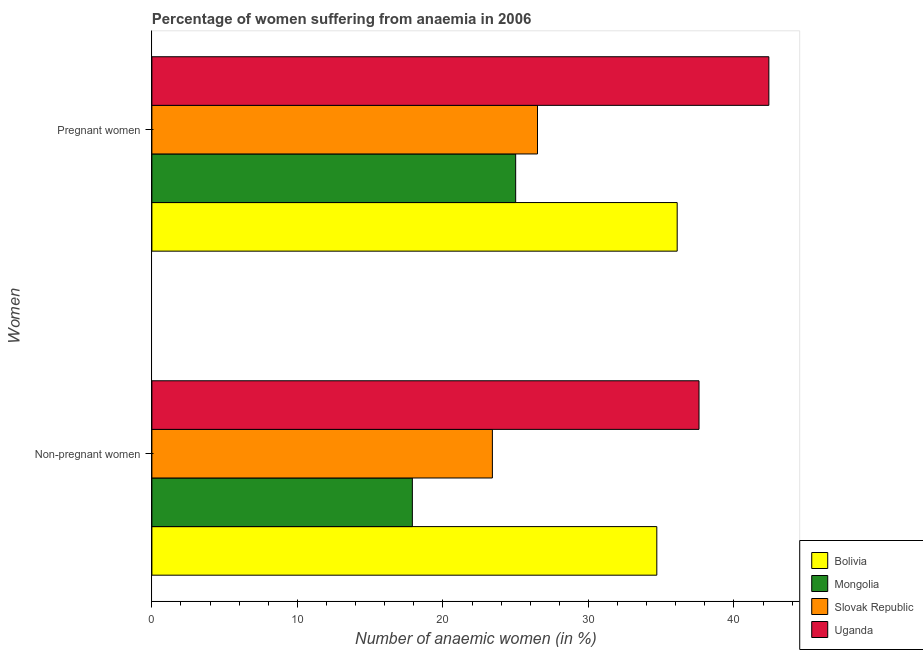How many different coloured bars are there?
Provide a short and direct response. 4. How many groups of bars are there?
Offer a very short reply. 2. How many bars are there on the 2nd tick from the top?
Ensure brevity in your answer.  4. How many bars are there on the 2nd tick from the bottom?
Keep it short and to the point. 4. What is the label of the 2nd group of bars from the top?
Offer a terse response. Non-pregnant women. What is the percentage of non-pregnant anaemic women in Bolivia?
Your answer should be compact. 34.7. Across all countries, what is the maximum percentage of pregnant anaemic women?
Offer a very short reply. 42.4. In which country was the percentage of non-pregnant anaemic women maximum?
Make the answer very short. Uganda. In which country was the percentage of non-pregnant anaemic women minimum?
Provide a succinct answer. Mongolia. What is the total percentage of pregnant anaemic women in the graph?
Your response must be concise. 130. What is the difference between the percentage of non-pregnant anaemic women in Slovak Republic and that in Mongolia?
Your answer should be compact. 5.5. What is the difference between the percentage of non-pregnant anaemic women in Mongolia and the percentage of pregnant anaemic women in Uganda?
Give a very brief answer. -24.5. What is the average percentage of non-pregnant anaemic women per country?
Your response must be concise. 28.4. What is the difference between the percentage of non-pregnant anaemic women and percentage of pregnant anaemic women in Uganda?
Your answer should be very brief. -4.8. What is the ratio of the percentage of non-pregnant anaemic women in Bolivia to that in Uganda?
Make the answer very short. 0.92. In how many countries, is the percentage of pregnant anaemic women greater than the average percentage of pregnant anaemic women taken over all countries?
Make the answer very short. 2. What does the 1st bar from the top in Pregnant women represents?
Ensure brevity in your answer.  Uganda. What does the 3rd bar from the bottom in Non-pregnant women represents?
Ensure brevity in your answer.  Slovak Republic. How many bars are there?
Keep it short and to the point. 8. Are all the bars in the graph horizontal?
Your answer should be compact. Yes. What is the difference between two consecutive major ticks on the X-axis?
Keep it short and to the point. 10. Are the values on the major ticks of X-axis written in scientific E-notation?
Provide a succinct answer. No. Does the graph contain any zero values?
Make the answer very short. No. Where does the legend appear in the graph?
Your answer should be very brief. Bottom right. How many legend labels are there?
Your answer should be very brief. 4. What is the title of the graph?
Provide a succinct answer. Percentage of women suffering from anaemia in 2006. Does "Samoa" appear as one of the legend labels in the graph?
Your answer should be compact. No. What is the label or title of the X-axis?
Offer a very short reply. Number of anaemic women (in %). What is the label or title of the Y-axis?
Your response must be concise. Women. What is the Number of anaemic women (in %) in Bolivia in Non-pregnant women?
Offer a very short reply. 34.7. What is the Number of anaemic women (in %) in Mongolia in Non-pregnant women?
Ensure brevity in your answer.  17.9. What is the Number of anaemic women (in %) in Slovak Republic in Non-pregnant women?
Ensure brevity in your answer.  23.4. What is the Number of anaemic women (in %) of Uganda in Non-pregnant women?
Ensure brevity in your answer.  37.6. What is the Number of anaemic women (in %) of Bolivia in Pregnant women?
Your answer should be very brief. 36.1. What is the Number of anaemic women (in %) of Mongolia in Pregnant women?
Keep it short and to the point. 25. What is the Number of anaemic women (in %) in Uganda in Pregnant women?
Make the answer very short. 42.4. Across all Women, what is the maximum Number of anaemic women (in %) in Bolivia?
Provide a succinct answer. 36.1. Across all Women, what is the maximum Number of anaemic women (in %) of Mongolia?
Provide a succinct answer. 25. Across all Women, what is the maximum Number of anaemic women (in %) of Slovak Republic?
Offer a terse response. 26.5. Across all Women, what is the maximum Number of anaemic women (in %) of Uganda?
Offer a terse response. 42.4. Across all Women, what is the minimum Number of anaemic women (in %) in Bolivia?
Ensure brevity in your answer.  34.7. Across all Women, what is the minimum Number of anaemic women (in %) of Slovak Republic?
Your response must be concise. 23.4. Across all Women, what is the minimum Number of anaemic women (in %) of Uganda?
Your answer should be very brief. 37.6. What is the total Number of anaemic women (in %) in Bolivia in the graph?
Your answer should be compact. 70.8. What is the total Number of anaemic women (in %) in Mongolia in the graph?
Make the answer very short. 42.9. What is the total Number of anaemic women (in %) in Slovak Republic in the graph?
Your response must be concise. 49.9. What is the total Number of anaemic women (in %) in Uganda in the graph?
Keep it short and to the point. 80. What is the difference between the Number of anaemic women (in %) in Bolivia in Non-pregnant women and that in Pregnant women?
Give a very brief answer. -1.4. What is the difference between the Number of anaemic women (in %) of Mongolia in Non-pregnant women and that in Pregnant women?
Keep it short and to the point. -7.1. What is the difference between the Number of anaemic women (in %) in Slovak Republic in Non-pregnant women and that in Pregnant women?
Give a very brief answer. -3.1. What is the difference between the Number of anaemic women (in %) in Bolivia in Non-pregnant women and the Number of anaemic women (in %) in Mongolia in Pregnant women?
Provide a short and direct response. 9.7. What is the difference between the Number of anaemic women (in %) in Bolivia in Non-pregnant women and the Number of anaemic women (in %) in Slovak Republic in Pregnant women?
Provide a succinct answer. 8.2. What is the difference between the Number of anaemic women (in %) in Bolivia in Non-pregnant women and the Number of anaemic women (in %) in Uganda in Pregnant women?
Offer a terse response. -7.7. What is the difference between the Number of anaemic women (in %) in Mongolia in Non-pregnant women and the Number of anaemic women (in %) in Uganda in Pregnant women?
Offer a terse response. -24.5. What is the average Number of anaemic women (in %) in Bolivia per Women?
Give a very brief answer. 35.4. What is the average Number of anaemic women (in %) in Mongolia per Women?
Ensure brevity in your answer.  21.45. What is the average Number of anaemic women (in %) of Slovak Republic per Women?
Ensure brevity in your answer.  24.95. What is the difference between the Number of anaemic women (in %) of Mongolia and Number of anaemic women (in %) of Slovak Republic in Non-pregnant women?
Provide a succinct answer. -5.5. What is the difference between the Number of anaemic women (in %) of Mongolia and Number of anaemic women (in %) of Uganda in Non-pregnant women?
Your answer should be very brief. -19.7. What is the difference between the Number of anaemic women (in %) in Slovak Republic and Number of anaemic women (in %) in Uganda in Non-pregnant women?
Provide a short and direct response. -14.2. What is the difference between the Number of anaemic women (in %) in Bolivia and Number of anaemic women (in %) in Mongolia in Pregnant women?
Make the answer very short. 11.1. What is the difference between the Number of anaemic women (in %) in Bolivia and Number of anaemic women (in %) in Slovak Republic in Pregnant women?
Give a very brief answer. 9.6. What is the difference between the Number of anaemic women (in %) of Bolivia and Number of anaemic women (in %) of Uganda in Pregnant women?
Make the answer very short. -6.3. What is the difference between the Number of anaemic women (in %) in Mongolia and Number of anaemic women (in %) in Uganda in Pregnant women?
Provide a succinct answer. -17.4. What is the difference between the Number of anaemic women (in %) in Slovak Republic and Number of anaemic women (in %) in Uganda in Pregnant women?
Offer a terse response. -15.9. What is the ratio of the Number of anaemic women (in %) of Bolivia in Non-pregnant women to that in Pregnant women?
Keep it short and to the point. 0.96. What is the ratio of the Number of anaemic women (in %) in Mongolia in Non-pregnant women to that in Pregnant women?
Provide a succinct answer. 0.72. What is the ratio of the Number of anaemic women (in %) in Slovak Republic in Non-pregnant women to that in Pregnant women?
Your response must be concise. 0.88. What is the ratio of the Number of anaemic women (in %) of Uganda in Non-pregnant women to that in Pregnant women?
Ensure brevity in your answer.  0.89. What is the difference between the highest and the second highest Number of anaemic women (in %) in Bolivia?
Give a very brief answer. 1.4. What is the difference between the highest and the lowest Number of anaemic women (in %) in Bolivia?
Offer a very short reply. 1.4. What is the difference between the highest and the lowest Number of anaemic women (in %) of Mongolia?
Ensure brevity in your answer.  7.1. What is the difference between the highest and the lowest Number of anaemic women (in %) in Slovak Republic?
Offer a very short reply. 3.1. 